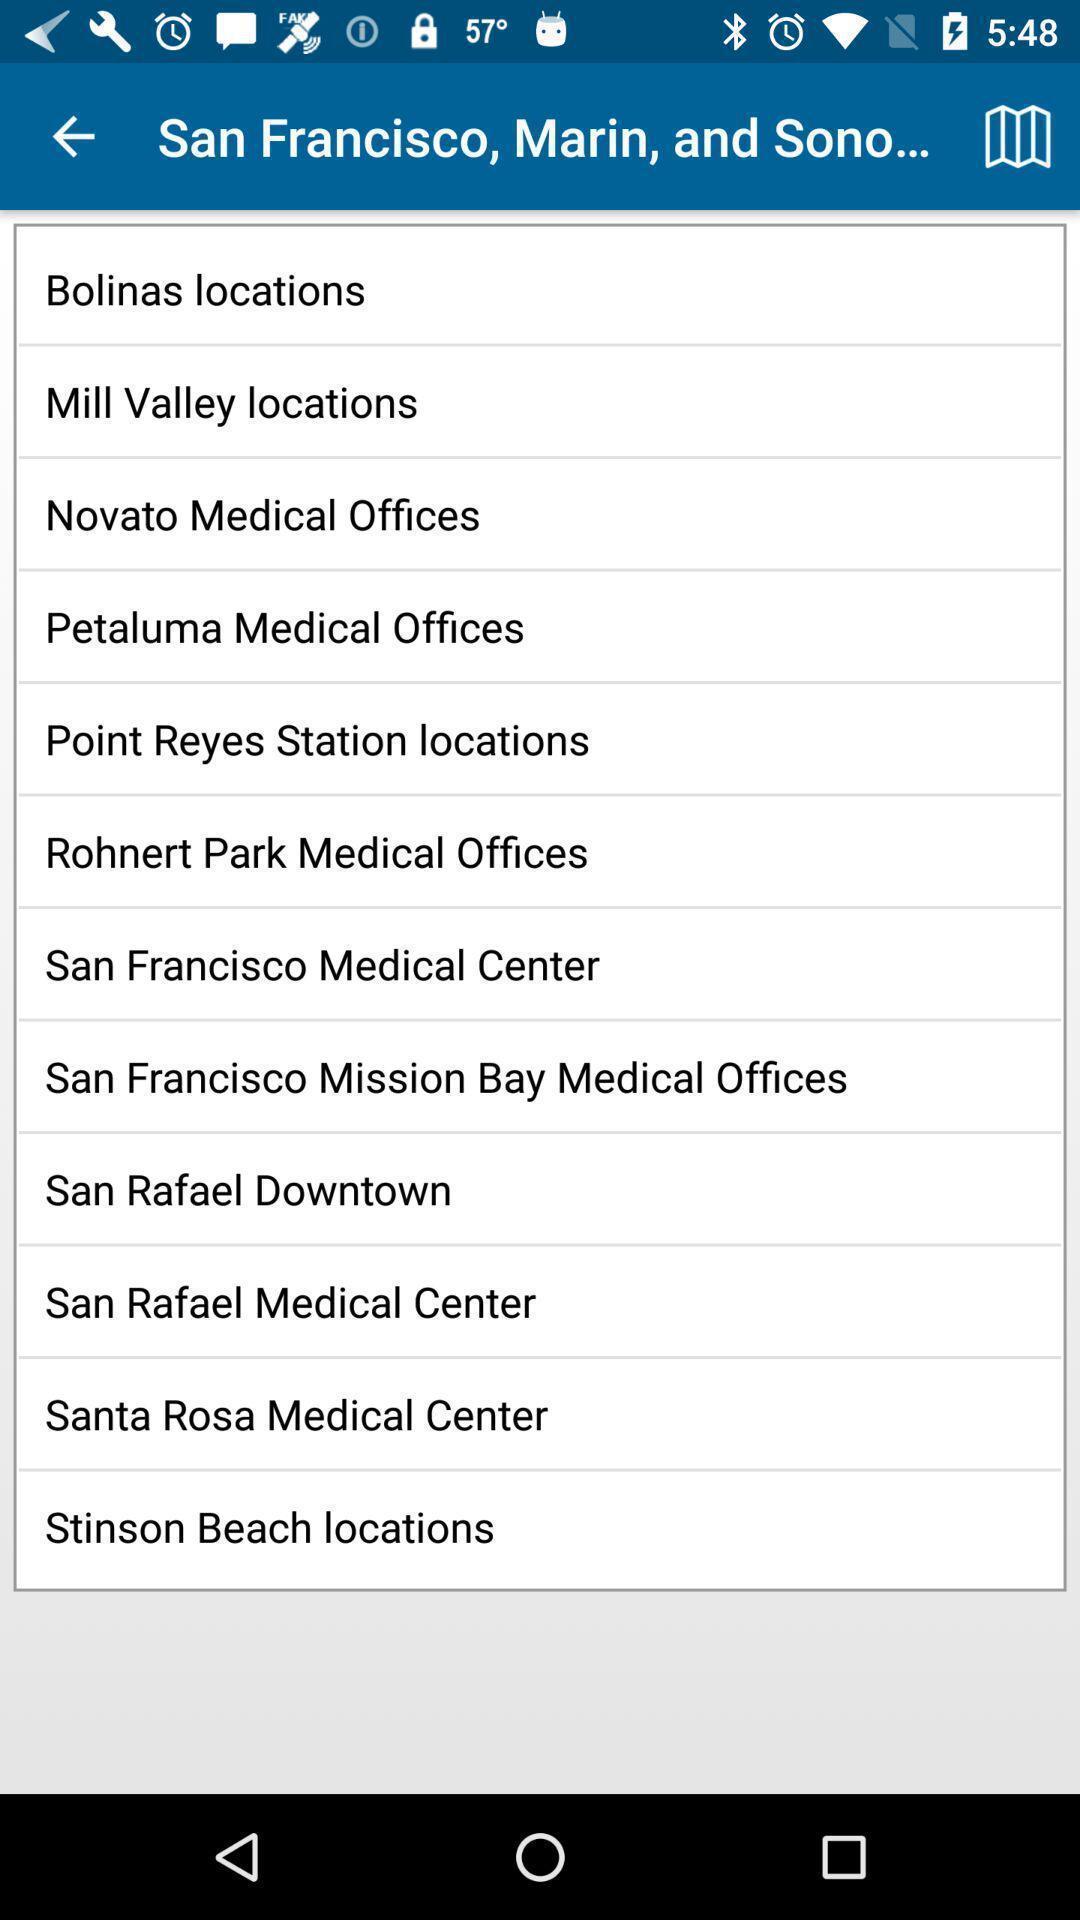Describe the key features of this screenshot. Screen displaying list of offices. 